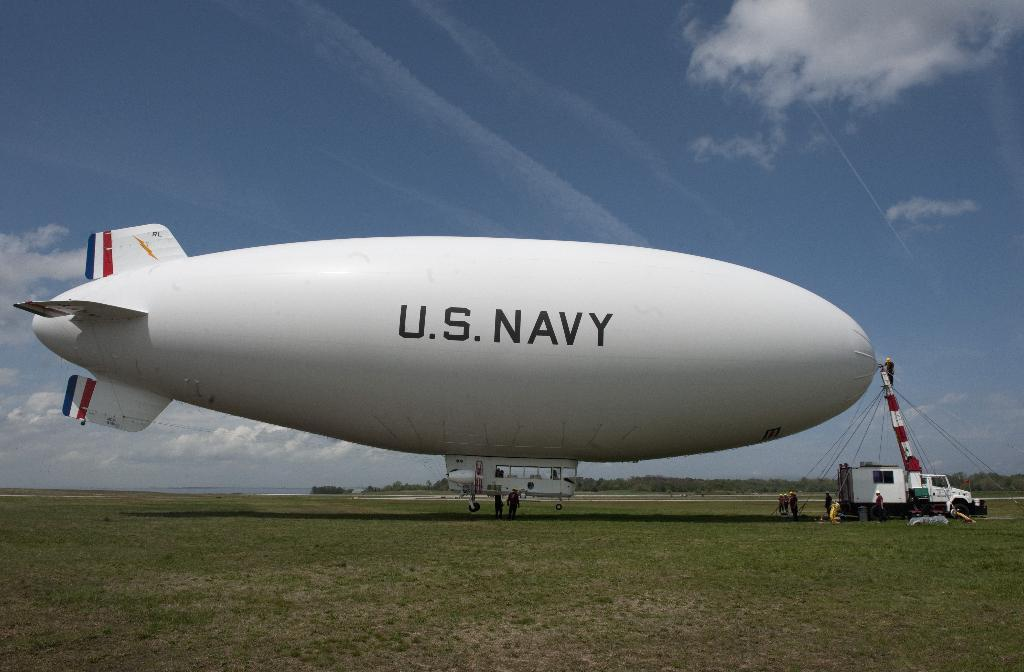Provide a one-sentence caption for the provided image. A hot air blimp is being set up by the U.S. Navy in a field. 